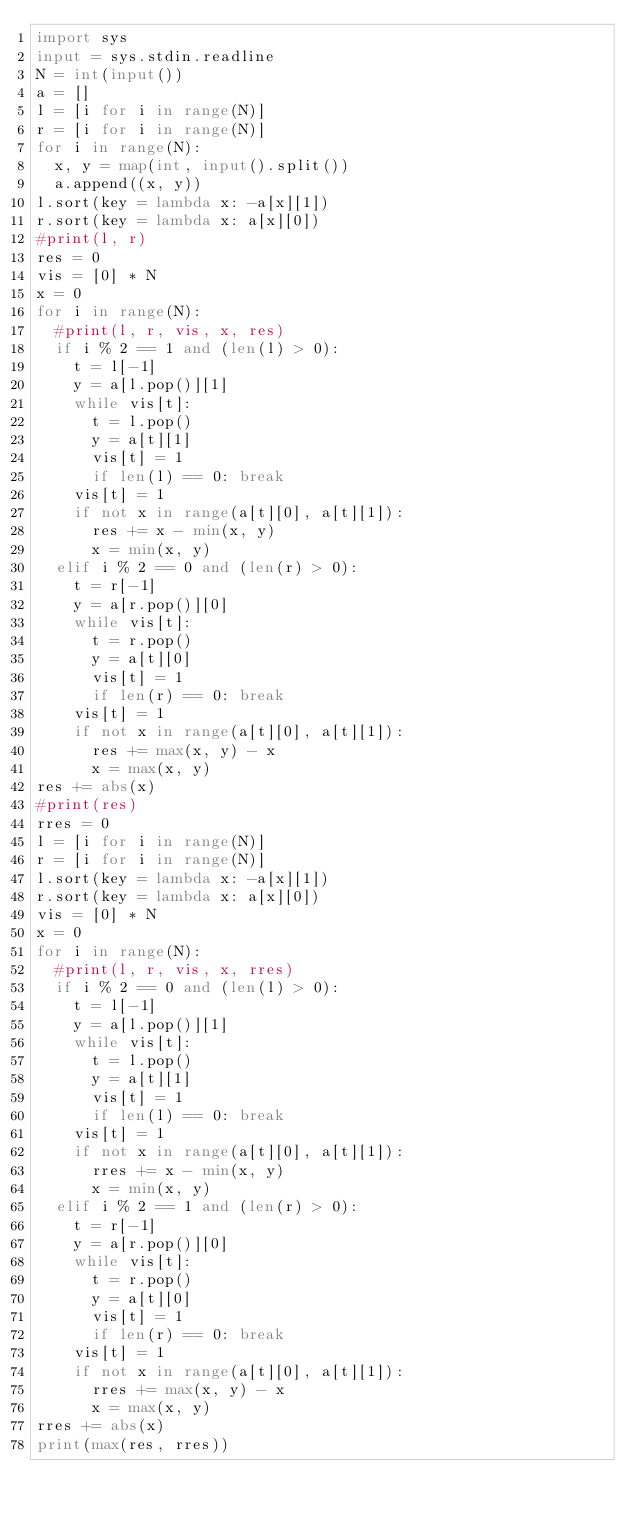<code> <loc_0><loc_0><loc_500><loc_500><_Python_>import sys
input = sys.stdin.readline
N = int(input())
a = []
l = [i for i in range(N)]
r = [i for i in range(N)]
for i in range(N):
  x, y = map(int, input().split())
  a.append((x, y))
l.sort(key = lambda x: -a[x][1])
r.sort(key = lambda x: a[x][0])
#print(l, r)
res = 0
vis = [0] * N
x = 0
for i in range(N):
  #print(l, r, vis, x, res)
  if i % 2 == 1 and (len(l) > 0):
    t = l[-1]
    y = a[l.pop()][1]
    while vis[t]:
      t = l.pop()
      y = a[t][1]
      vis[t] = 1
      if len(l) == 0: break
    vis[t] = 1
    if not x in range(a[t][0], a[t][1]):
      res += x - min(x, y)
      x = min(x, y)
  elif i % 2 == 0 and (len(r) > 0):
    t = r[-1]
    y = a[r.pop()][0]
    while vis[t]:
      t = r.pop()
      y = a[t][0]
      vis[t] = 1
      if len(r) == 0: break
    vis[t] = 1
    if not x in range(a[t][0], a[t][1]):
      res += max(x, y) - x
      x = max(x, y)
res += abs(x)
#print(res)
rres = 0
l = [i for i in range(N)]
r = [i for i in range(N)]
l.sort(key = lambda x: -a[x][1])
r.sort(key = lambda x: a[x][0])
vis = [0] * N
x = 0
for i in range(N):
  #print(l, r, vis, x, rres)
  if i % 2 == 0 and (len(l) > 0):
    t = l[-1]
    y = a[l.pop()][1]
    while vis[t]:
      t = l.pop()
      y = a[t][1]
      vis[t] = 1
      if len(l) == 0: break
    vis[t] = 1
    if not x in range(a[t][0], a[t][1]):
      rres += x - min(x, y)
      x = min(x, y)
  elif i % 2 == 1 and (len(r) > 0):
    t = r[-1]
    y = a[r.pop()][0]
    while vis[t]:
      t = r.pop()
      y = a[t][0]
      vis[t] = 1
      if len(r) == 0: break
    vis[t] = 1
    if not x in range(a[t][0], a[t][1]):
      rres += max(x, y) - x
      x = max(x, y)
rres += abs(x)
print(max(res, rres))</code> 